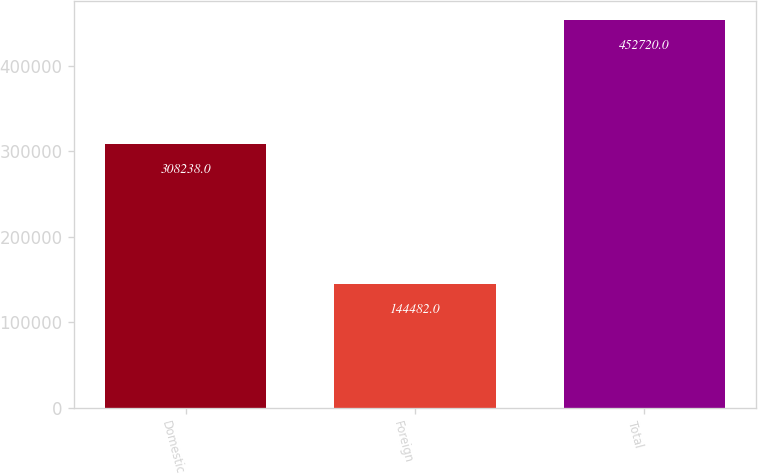<chart> <loc_0><loc_0><loc_500><loc_500><bar_chart><fcel>Domestic<fcel>Foreign<fcel>Total<nl><fcel>308238<fcel>144482<fcel>452720<nl></chart> 